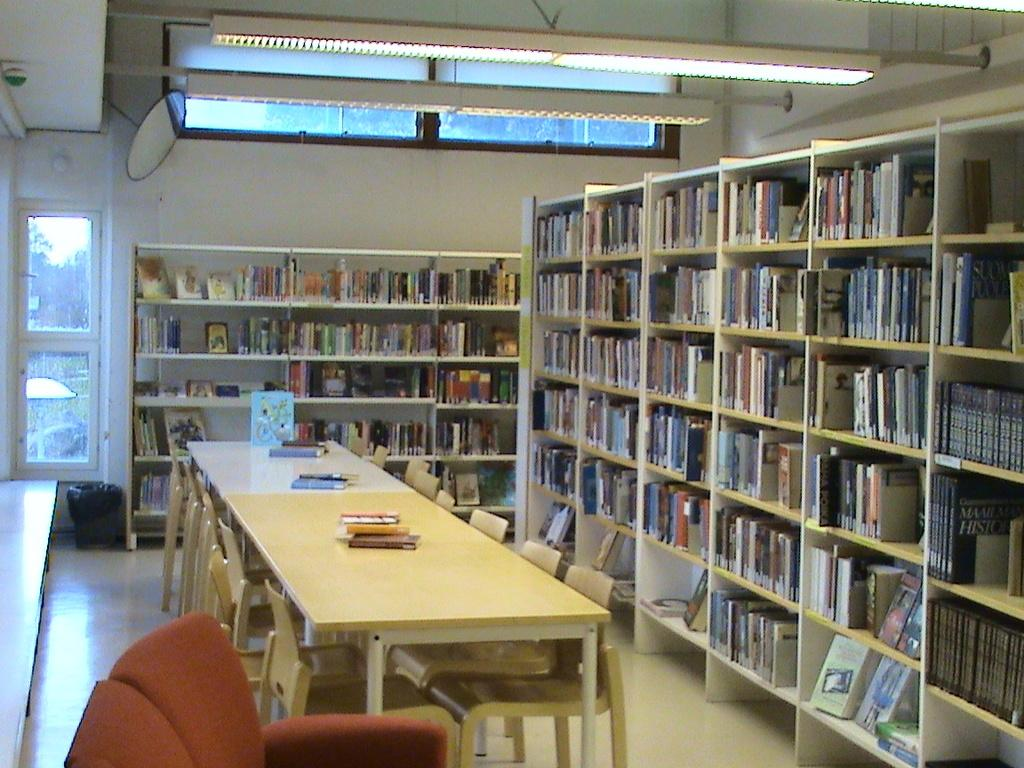<image>
Describe the image concisely. Library full of books and has one black book that says "HISTORY". 